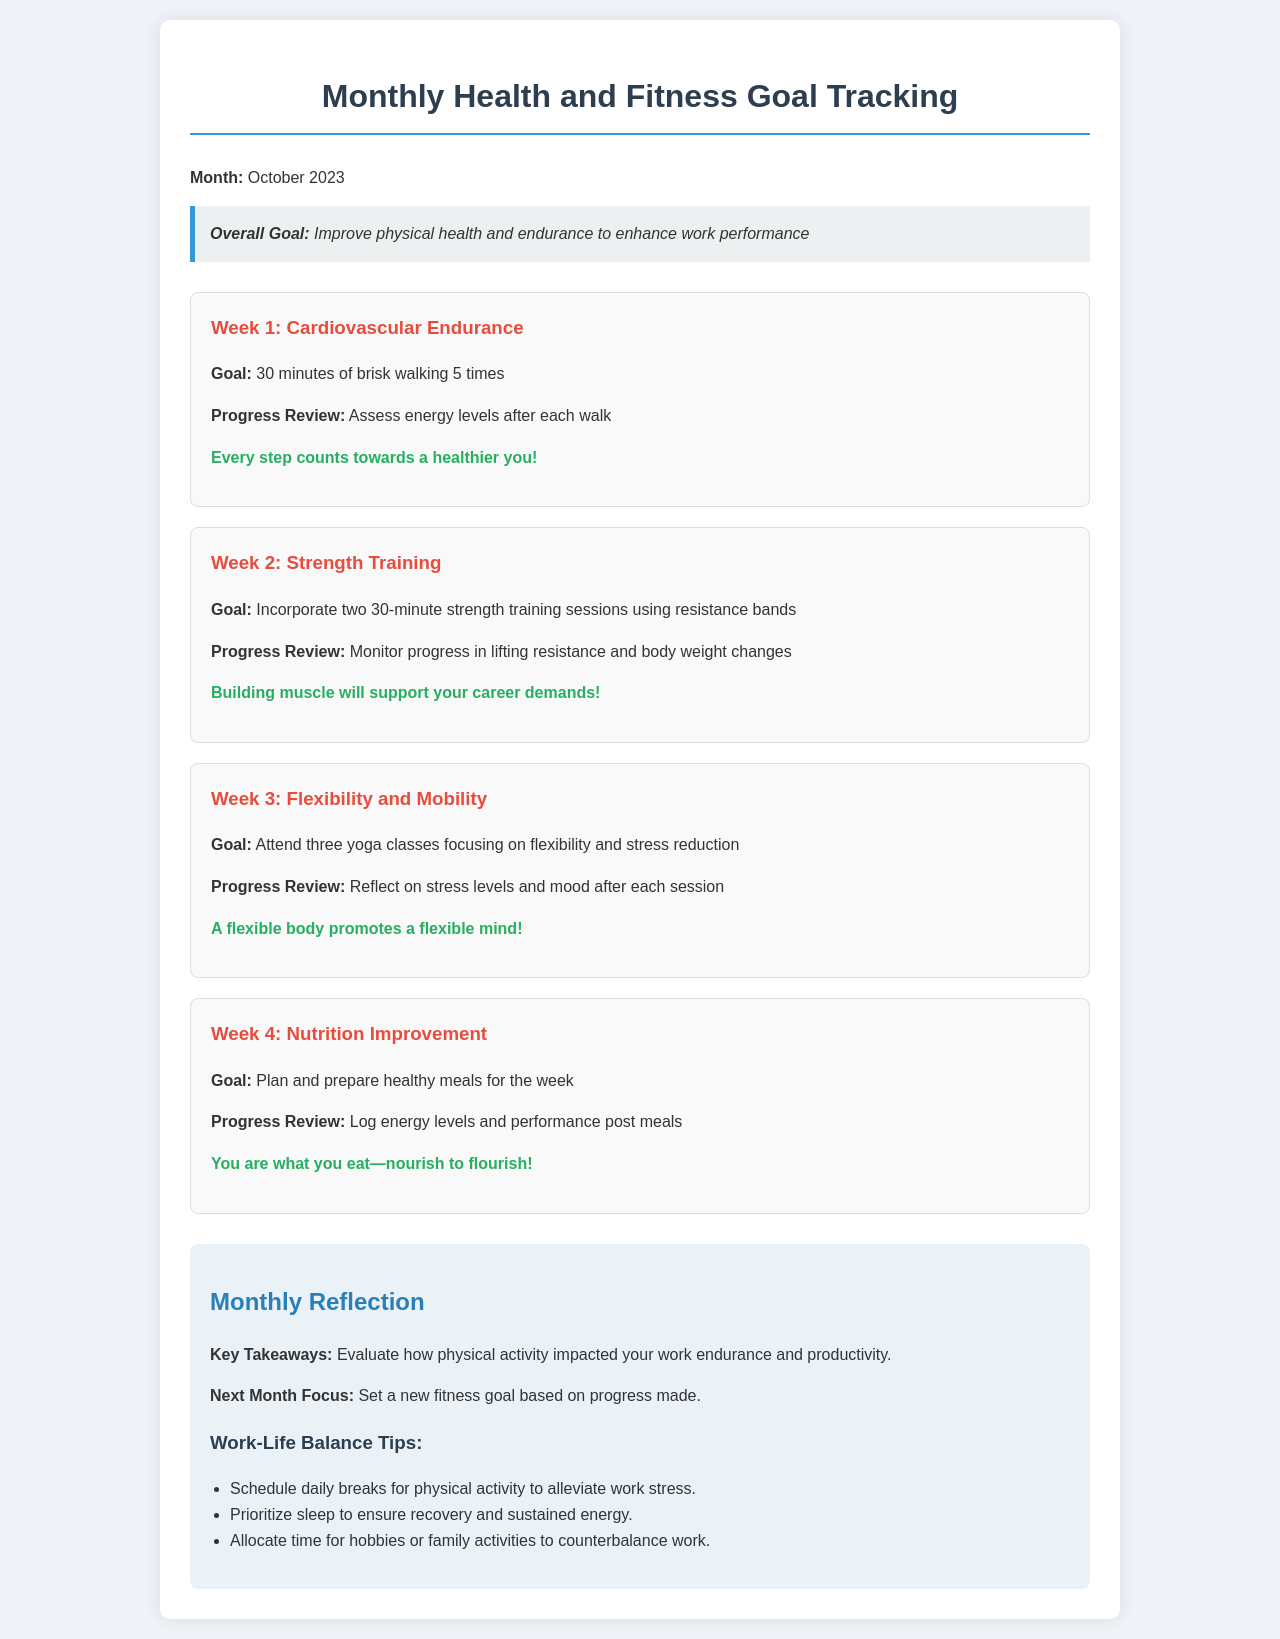What is the overall goal for October 2023? The overall goal is mentioned at the top of the document, emphasizing improvement in physical health and endurance for work performance.
Answer: Improve physical health and endurance to enhance work performance What is the goal for Week 1? Week 1 focuses on cardiovascular endurance, and the specific goal is stated clearly in the section for that week.
Answer: 30 minutes of brisk walking 5 times How many yoga classes are planned for Week 3? The document specifies the number of yoga classes intended for Week 3, which is important for flexibility and stress reduction.
Answer: Three classes What type of training is highlighted in Week 2? Week 2 focuses on a specific type of training, indicated clearly in the section dedicated to that week.
Answer: Strength training What should be logged during Week 4's progress review? The document states what needs to be logged in preparation for healthy meals during the week in Week 4.
Answer: Energy levels and performance post meals How does physical activity impact work endurance according to the Monthly Reflection? The Monthly Reflection section explores the relationship between physical activity and its impact on work performance.
Answer: Evaluates impact on endurance and productivity What should be prioritized for recovery? The document highlights an important aspect of health that contributes to recovery, specifically mentioned in the work-life balance tips.
Answer: Sleep What is the focus for next month? The Monthly Reflection section includes guidance for setting future goals based on current progress.
Answer: Set a new fitness goal based on progress made 